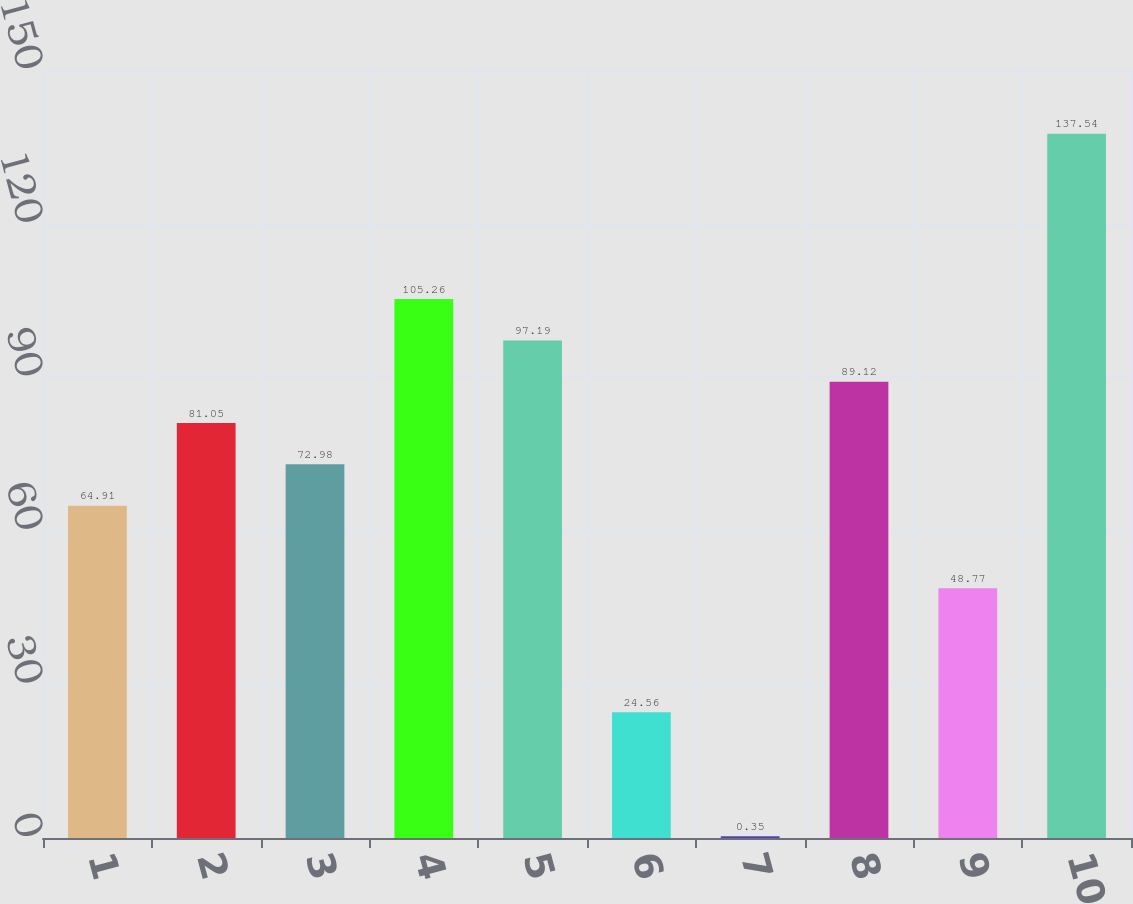Convert chart to OTSL. <chart><loc_0><loc_0><loc_500><loc_500><bar_chart><fcel>1<fcel>2<fcel>3<fcel>4<fcel>5<fcel>6<fcel>7<fcel>8<fcel>9<fcel>10<nl><fcel>64.91<fcel>81.05<fcel>72.98<fcel>105.26<fcel>97.19<fcel>24.56<fcel>0.35<fcel>89.12<fcel>48.77<fcel>137.54<nl></chart> 